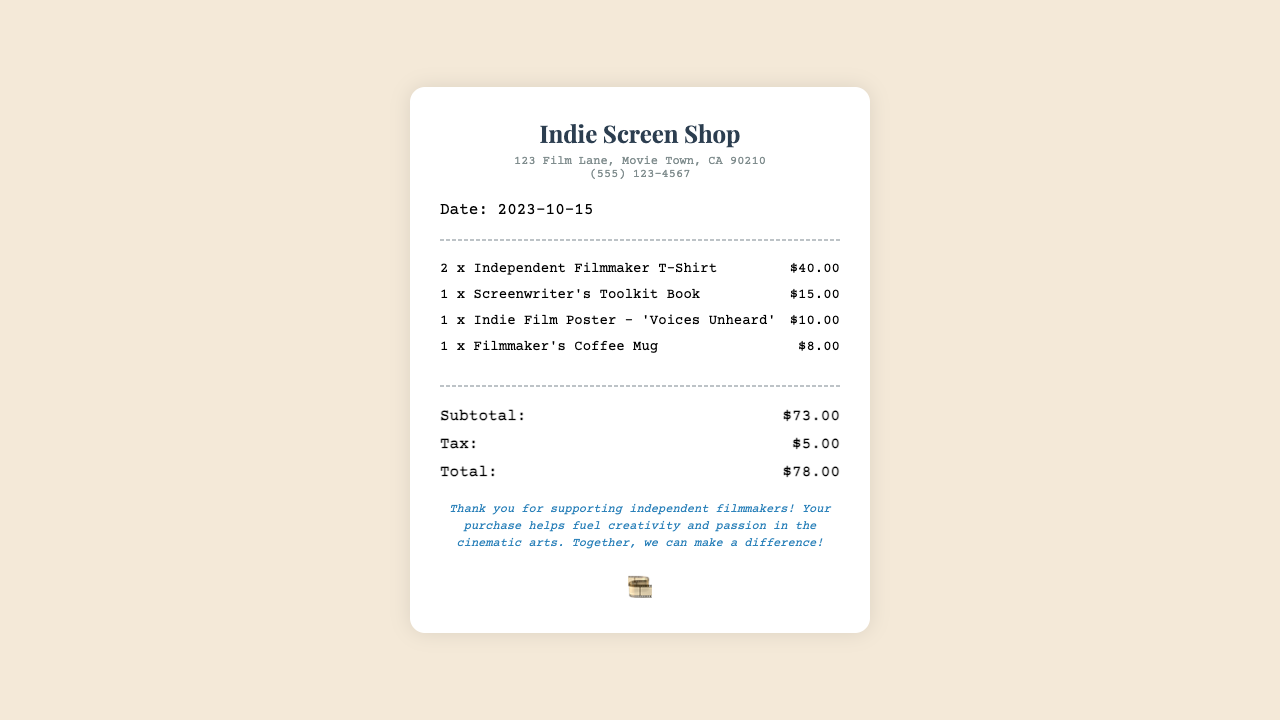What is the date of the receipt? The date is mentioned at the top of the receipt under the "Date" section.
Answer: 2023-10-15 How many Independent Filmmaker T-Shirts were purchased? The number of T-shirts purchased is specified in the item list.
Answer: 2 What is the price of the Screenwriter's Toolkit Book? The price is listed alongside the item in the receipt.
Answer: $15.00 What is the subtotal amount before tax? The subtotal is clearly indicated in the totals section of the receipt.
Answer: $73.00 What was the total amount spent including tax? The total amount is provided at the end of the totals section.
Answer: $78.00 Which item has the lowest price? This can be determined by comparing the prices of all items listed in the receipt.
Answer: Filmmaker's Coffee Mug What does the thank-you note express? The note expresses gratitude for supporting a specific group.
Answer: Independent filmmakers How many items were included in the purchase? This requires counting each item listed in the receipt.
Answer: 4 What is the store's phone number? The contact information is located in the store info section.
Answer: (555) 123-4567 